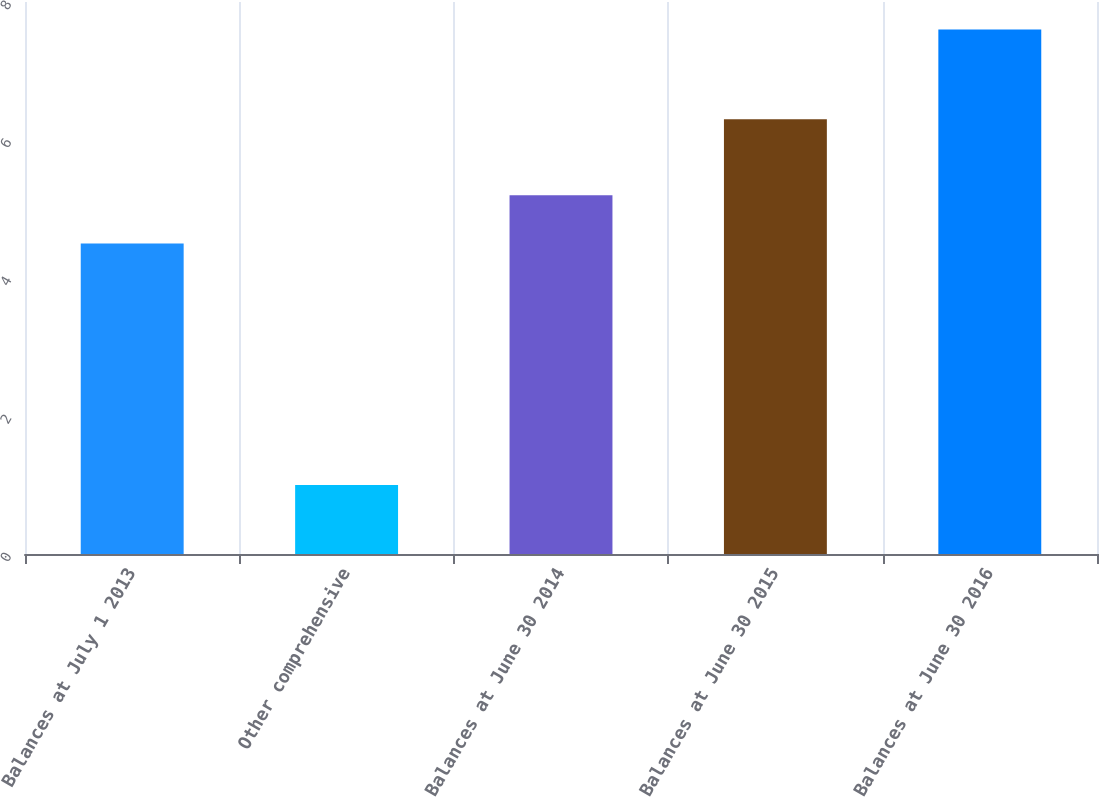<chart> <loc_0><loc_0><loc_500><loc_500><bar_chart><fcel>Balances at July 1 2013<fcel>Other comprehensive<fcel>Balances at June 30 2014<fcel>Balances at June 30 2015<fcel>Balances at June 30 2016<nl><fcel>4.5<fcel>1<fcel>5.2<fcel>6.3<fcel>7.6<nl></chart> 